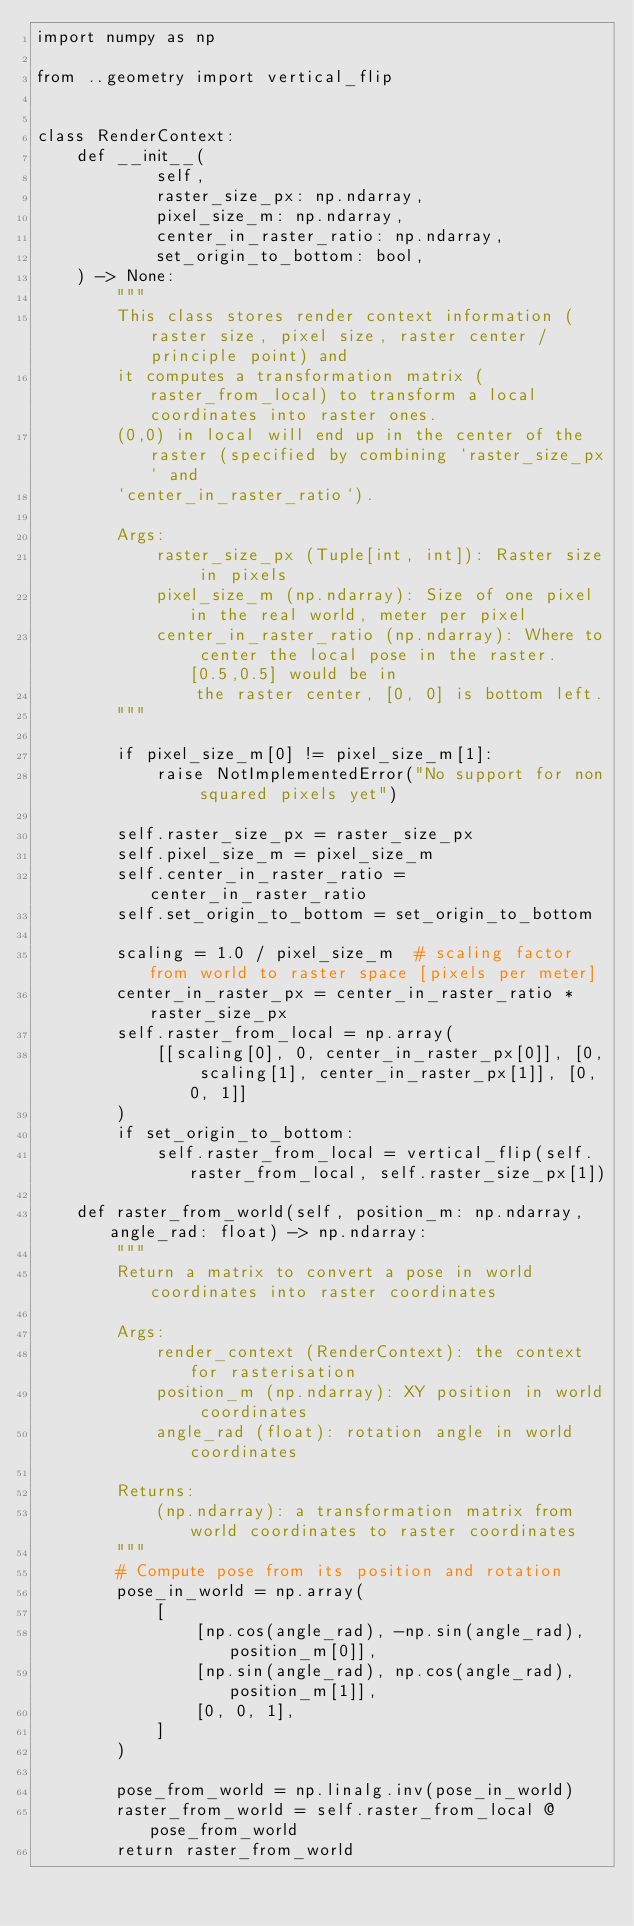Convert code to text. <code><loc_0><loc_0><loc_500><loc_500><_Python_>import numpy as np

from ..geometry import vertical_flip


class RenderContext:
    def __init__(
            self,
            raster_size_px: np.ndarray,
            pixel_size_m: np.ndarray,
            center_in_raster_ratio: np.ndarray,
            set_origin_to_bottom: bool,
    ) -> None:
        """
        This class stores render context information (raster size, pixel size, raster center / principle point) and
        it computes a transformation matrix (raster_from_local) to transform a local coordinates into raster ones.
        (0,0) in local will end up in the center of the raster (specified by combining `raster_size_px` and
        `center_in_raster_ratio`).

        Args:
            raster_size_px (Tuple[int, int]): Raster size in pixels
            pixel_size_m (np.ndarray): Size of one pixel in the real world, meter per pixel
            center_in_raster_ratio (np.ndarray): Where to center the local pose in the raster. [0.5,0.5] would be in
                the raster center, [0, 0] is bottom left.
        """

        if pixel_size_m[0] != pixel_size_m[1]:
            raise NotImplementedError("No support for non squared pixels yet")

        self.raster_size_px = raster_size_px
        self.pixel_size_m = pixel_size_m
        self.center_in_raster_ratio = center_in_raster_ratio
        self.set_origin_to_bottom = set_origin_to_bottom

        scaling = 1.0 / pixel_size_m  # scaling factor from world to raster space [pixels per meter]
        center_in_raster_px = center_in_raster_ratio * raster_size_px
        self.raster_from_local = np.array(
            [[scaling[0], 0, center_in_raster_px[0]], [0, scaling[1], center_in_raster_px[1]], [0, 0, 1]]
        )
        if set_origin_to_bottom:
            self.raster_from_local = vertical_flip(self.raster_from_local, self.raster_size_px[1])

    def raster_from_world(self, position_m: np.ndarray, angle_rad: float) -> np.ndarray:
        """
        Return a matrix to convert a pose in world coordinates into raster coordinates

        Args:
            render_context (RenderContext): the context for rasterisation
            position_m (np.ndarray): XY position in world coordinates
            angle_rad (float): rotation angle in world coordinates

        Returns:
            (np.ndarray): a transformation matrix from world coordinates to raster coordinates
        """
        # Compute pose from its position and rotation
        pose_in_world = np.array(
            [
                [np.cos(angle_rad), -np.sin(angle_rad), position_m[0]],
                [np.sin(angle_rad), np.cos(angle_rad), position_m[1]],
                [0, 0, 1],
            ]
        )

        pose_from_world = np.linalg.inv(pose_in_world)
        raster_from_world = self.raster_from_local @ pose_from_world
        return raster_from_world
</code> 